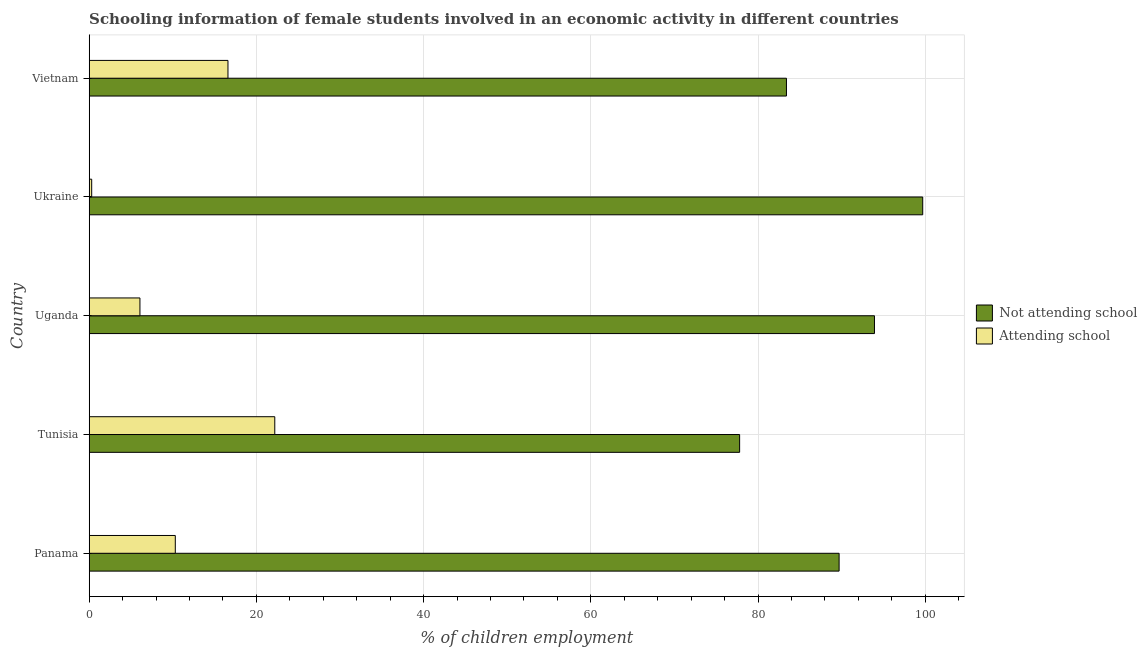How many different coloured bars are there?
Your response must be concise. 2. How many bars are there on the 4th tick from the bottom?
Your response must be concise. 2. What is the label of the 4th group of bars from the top?
Your answer should be compact. Tunisia. In how many cases, is the number of bars for a given country not equal to the number of legend labels?
Your answer should be very brief. 0. What is the percentage of employed females who are attending school in Vietnam?
Ensure brevity in your answer.  16.6. Across all countries, what is the maximum percentage of employed females who are not attending school?
Make the answer very short. 99.7. Across all countries, what is the minimum percentage of employed females who are not attending school?
Make the answer very short. 77.8. In which country was the percentage of employed females who are not attending school maximum?
Provide a succinct answer. Ukraine. In which country was the percentage of employed females who are not attending school minimum?
Offer a very short reply. Tunisia. What is the total percentage of employed females who are not attending school in the graph?
Keep it short and to the point. 444.53. What is the difference between the percentage of employed females who are not attending school in Panama and the percentage of employed females who are attending school in Ukraine?
Provide a short and direct response. 89.4. What is the average percentage of employed females who are not attending school per country?
Your answer should be compact. 88.91. What is the difference between the percentage of employed females who are not attending school and percentage of employed females who are attending school in Panama?
Keep it short and to the point. 79.4. What is the ratio of the percentage of employed females who are not attending school in Tunisia to that in Uganda?
Your response must be concise. 0.83. Is the percentage of employed females who are attending school in Ukraine less than that in Vietnam?
Offer a terse response. Yes. What is the difference between the highest and the lowest percentage of employed females who are not attending school?
Your answer should be compact. 21.9. In how many countries, is the percentage of employed females who are not attending school greater than the average percentage of employed females who are not attending school taken over all countries?
Ensure brevity in your answer.  3. What does the 2nd bar from the top in Tunisia represents?
Your answer should be compact. Not attending school. What does the 1st bar from the bottom in Uganda represents?
Your answer should be compact. Not attending school. Are all the bars in the graph horizontal?
Your answer should be compact. Yes. How many countries are there in the graph?
Keep it short and to the point. 5. Are the values on the major ticks of X-axis written in scientific E-notation?
Offer a terse response. No. Does the graph contain grids?
Ensure brevity in your answer.  Yes. Where does the legend appear in the graph?
Offer a terse response. Center right. How many legend labels are there?
Give a very brief answer. 2. How are the legend labels stacked?
Your answer should be very brief. Vertical. What is the title of the graph?
Your response must be concise. Schooling information of female students involved in an economic activity in different countries. What is the label or title of the X-axis?
Provide a succinct answer. % of children employment. What is the label or title of the Y-axis?
Your answer should be compact. Country. What is the % of children employment of Not attending school in Panama?
Offer a terse response. 89.7. What is the % of children employment of Attending school in Panama?
Provide a succinct answer. 10.3. What is the % of children employment of Not attending school in Tunisia?
Ensure brevity in your answer.  77.8. What is the % of children employment in Attending school in Tunisia?
Provide a short and direct response. 22.2. What is the % of children employment in Not attending school in Uganda?
Offer a terse response. 93.93. What is the % of children employment of Attending school in Uganda?
Ensure brevity in your answer.  6.07. What is the % of children employment in Not attending school in Ukraine?
Your answer should be very brief. 99.7. What is the % of children employment of Not attending school in Vietnam?
Provide a succinct answer. 83.4. Across all countries, what is the maximum % of children employment in Not attending school?
Offer a terse response. 99.7. Across all countries, what is the maximum % of children employment in Attending school?
Your response must be concise. 22.2. Across all countries, what is the minimum % of children employment in Not attending school?
Offer a very short reply. 77.8. Across all countries, what is the minimum % of children employment of Attending school?
Keep it short and to the point. 0.3. What is the total % of children employment of Not attending school in the graph?
Provide a succinct answer. 444.53. What is the total % of children employment in Attending school in the graph?
Keep it short and to the point. 55.47. What is the difference between the % of children employment of Not attending school in Panama and that in Tunisia?
Your response must be concise. 11.9. What is the difference between the % of children employment in Not attending school in Panama and that in Uganda?
Your answer should be very brief. -4.23. What is the difference between the % of children employment of Attending school in Panama and that in Uganda?
Provide a succinct answer. 4.23. What is the difference between the % of children employment in Not attending school in Panama and that in Ukraine?
Ensure brevity in your answer.  -10. What is the difference between the % of children employment in Attending school in Panama and that in Ukraine?
Provide a succinct answer. 10. What is the difference between the % of children employment in Not attending school in Tunisia and that in Uganda?
Make the answer very short. -16.13. What is the difference between the % of children employment of Attending school in Tunisia and that in Uganda?
Offer a terse response. 16.13. What is the difference between the % of children employment of Not attending school in Tunisia and that in Ukraine?
Offer a terse response. -21.9. What is the difference between the % of children employment of Attending school in Tunisia and that in Ukraine?
Make the answer very short. 21.9. What is the difference between the % of children employment in Attending school in Tunisia and that in Vietnam?
Provide a short and direct response. 5.6. What is the difference between the % of children employment of Not attending school in Uganda and that in Ukraine?
Ensure brevity in your answer.  -5.77. What is the difference between the % of children employment of Attending school in Uganda and that in Ukraine?
Ensure brevity in your answer.  5.77. What is the difference between the % of children employment of Not attending school in Uganda and that in Vietnam?
Keep it short and to the point. 10.53. What is the difference between the % of children employment of Attending school in Uganda and that in Vietnam?
Offer a terse response. -10.53. What is the difference between the % of children employment of Attending school in Ukraine and that in Vietnam?
Provide a succinct answer. -16.3. What is the difference between the % of children employment in Not attending school in Panama and the % of children employment in Attending school in Tunisia?
Offer a terse response. 67.5. What is the difference between the % of children employment in Not attending school in Panama and the % of children employment in Attending school in Uganda?
Keep it short and to the point. 83.63. What is the difference between the % of children employment in Not attending school in Panama and the % of children employment in Attending school in Ukraine?
Provide a succinct answer. 89.4. What is the difference between the % of children employment in Not attending school in Panama and the % of children employment in Attending school in Vietnam?
Give a very brief answer. 73.1. What is the difference between the % of children employment in Not attending school in Tunisia and the % of children employment in Attending school in Uganda?
Give a very brief answer. 71.73. What is the difference between the % of children employment of Not attending school in Tunisia and the % of children employment of Attending school in Ukraine?
Provide a succinct answer. 77.5. What is the difference between the % of children employment of Not attending school in Tunisia and the % of children employment of Attending school in Vietnam?
Give a very brief answer. 61.2. What is the difference between the % of children employment in Not attending school in Uganda and the % of children employment in Attending school in Ukraine?
Offer a terse response. 93.63. What is the difference between the % of children employment in Not attending school in Uganda and the % of children employment in Attending school in Vietnam?
Your answer should be compact. 77.33. What is the difference between the % of children employment in Not attending school in Ukraine and the % of children employment in Attending school in Vietnam?
Your answer should be compact. 83.1. What is the average % of children employment of Not attending school per country?
Ensure brevity in your answer.  88.91. What is the average % of children employment in Attending school per country?
Ensure brevity in your answer.  11.09. What is the difference between the % of children employment of Not attending school and % of children employment of Attending school in Panama?
Provide a short and direct response. 79.4. What is the difference between the % of children employment in Not attending school and % of children employment in Attending school in Tunisia?
Offer a terse response. 55.6. What is the difference between the % of children employment in Not attending school and % of children employment in Attending school in Uganda?
Your answer should be very brief. 87.86. What is the difference between the % of children employment in Not attending school and % of children employment in Attending school in Ukraine?
Your answer should be very brief. 99.4. What is the difference between the % of children employment in Not attending school and % of children employment in Attending school in Vietnam?
Offer a terse response. 66.8. What is the ratio of the % of children employment in Not attending school in Panama to that in Tunisia?
Provide a short and direct response. 1.15. What is the ratio of the % of children employment of Attending school in Panama to that in Tunisia?
Offer a very short reply. 0.46. What is the ratio of the % of children employment in Not attending school in Panama to that in Uganda?
Offer a terse response. 0.95. What is the ratio of the % of children employment in Attending school in Panama to that in Uganda?
Give a very brief answer. 1.7. What is the ratio of the % of children employment in Not attending school in Panama to that in Ukraine?
Your response must be concise. 0.9. What is the ratio of the % of children employment of Attending school in Panama to that in Ukraine?
Ensure brevity in your answer.  34.33. What is the ratio of the % of children employment in Not attending school in Panama to that in Vietnam?
Give a very brief answer. 1.08. What is the ratio of the % of children employment of Attending school in Panama to that in Vietnam?
Your answer should be compact. 0.62. What is the ratio of the % of children employment of Not attending school in Tunisia to that in Uganda?
Provide a short and direct response. 0.83. What is the ratio of the % of children employment of Attending school in Tunisia to that in Uganda?
Give a very brief answer. 3.66. What is the ratio of the % of children employment of Not attending school in Tunisia to that in Ukraine?
Your answer should be very brief. 0.78. What is the ratio of the % of children employment in Not attending school in Tunisia to that in Vietnam?
Offer a very short reply. 0.93. What is the ratio of the % of children employment in Attending school in Tunisia to that in Vietnam?
Provide a short and direct response. 1.34. What is the ratio of the % of children employment in Not attending school in Uganda to that in Ukraine?
Provide a succinct answer. 0.94. What is the ratio of the % of children employment in Attending school in Uganda to that in Ukraine?
Offer a very short reply. 20.24. What is the ratio of the % of children employment in Not attending school in Uganda to that in Vietnam?
Give a very brief answer. 1.13. What is the ratio of the % of children employment of Attending school in Uganda to that in Vietnam?
Keep it short and to the point. 0.37. What is the ratio of the % of children employment in Not attending school in Ukraine to that in Vietnam?
Your answer should be compact. 1.2. What is the ratio of the % of children employment in Attending school in Ukraine to that in Vietnam?
Offer a very short reply. 0.02. What is the difference between the highest and the second highest % of children employment of Not attending school?
Offer a very short reply. 5.77. What is the difference between the highest and the second highest % of children employment of Attending school?
Your response must be concise. 5.6. What is the difference between the highest and the lowest % of children employment in Not attending school?
Your response must be concise. 21.9. What is the difference between the highest and the lowest % of children employment in Attending school?
Ensure brevity in your answer.  21.9. 